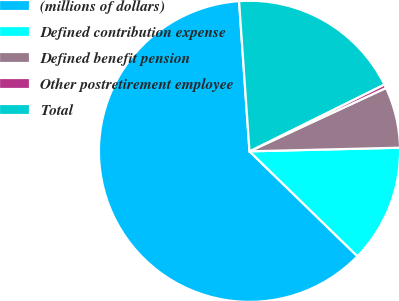Convert chart to OTSL. <chart><loc_0><loc_0><loc_500><loc_500><pie_chart><fcel>(millions of dollars)<fcel>Defined contribution expense<fcel>Defined benefit pension<fcel>Other postretirement employee<fcel>Total<nl><fcel>61.62%<fcel>12.66%<fcel>6.53%<fcel>0.41%<fcel>18.78%<nl></chart> 